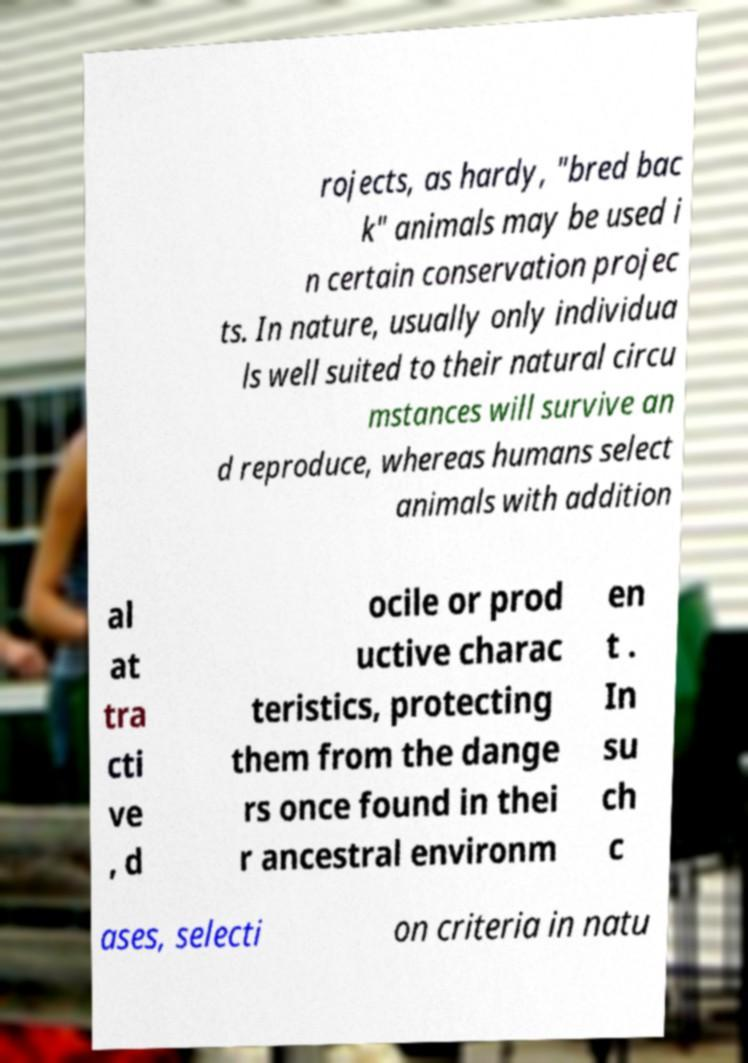Can you read and provide the text displayed in the image?This photo seems to have some interesting text. Can you extract and type it out for me? rojects, as hardy, "bred bac k" animals may be used i n certain conservation projec ts. In nature, usually only individua ls well suited to their natural circu mstances will survive an d reproduce, whereas humans select animals with addition al at tra cti ve , d ocile or prod uctive charac teristics, protecting them from the dange rs once found in thei r ancestral environm en t . In su ch c ases, selecti on criteria in natu 